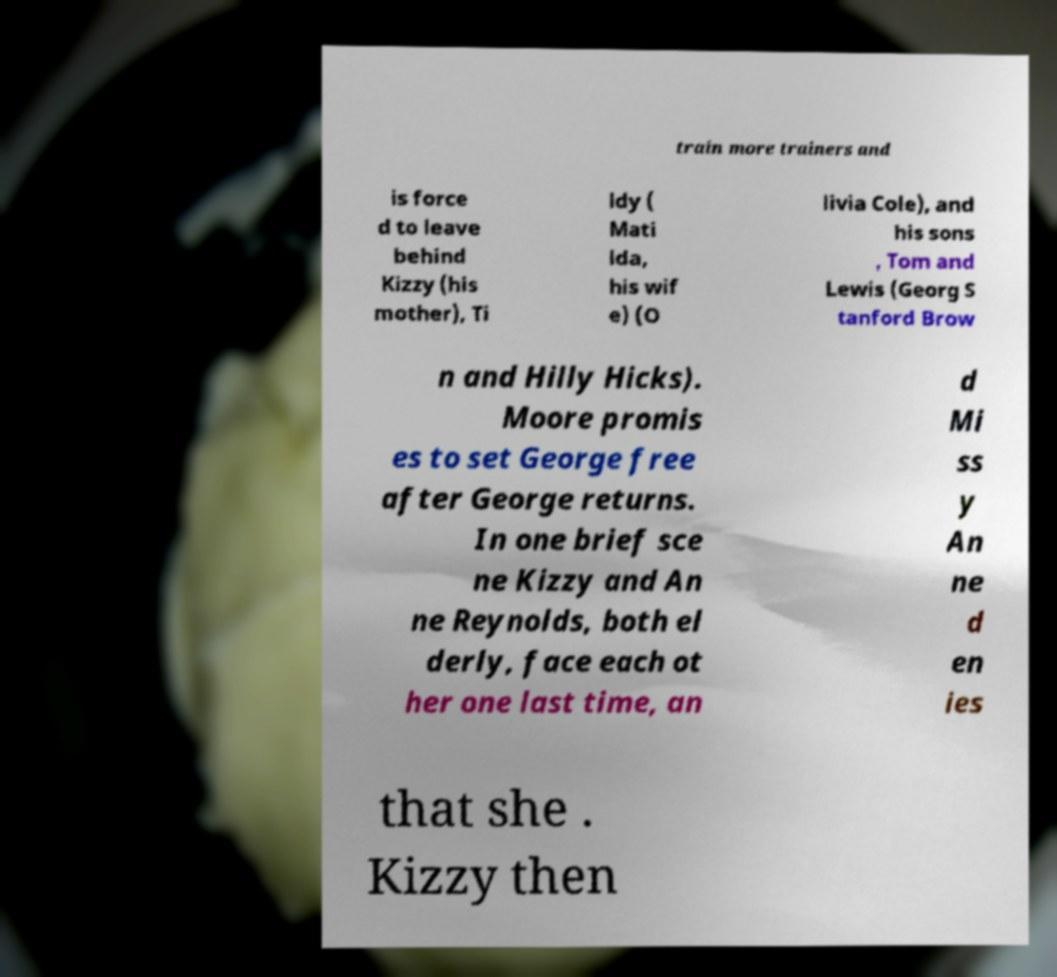For documentation purposes, I need the text within this image transcribed. Could you provide that? train more trainers and is force d to leave behind Kizzy (his mother), Ti ldy ( Mati lda, his wif e) (O livia Cole), and his sons , Tom and Lewis (Georg S tanford Brow n and Hilly Hicks). Moore promis es to set George free after George returns. In one brief sce ne Kizzy and An ne Reynolds, both el derly, face each ot her one last time, an d Mi ss y An ne d en ies that she . Kizzy then 